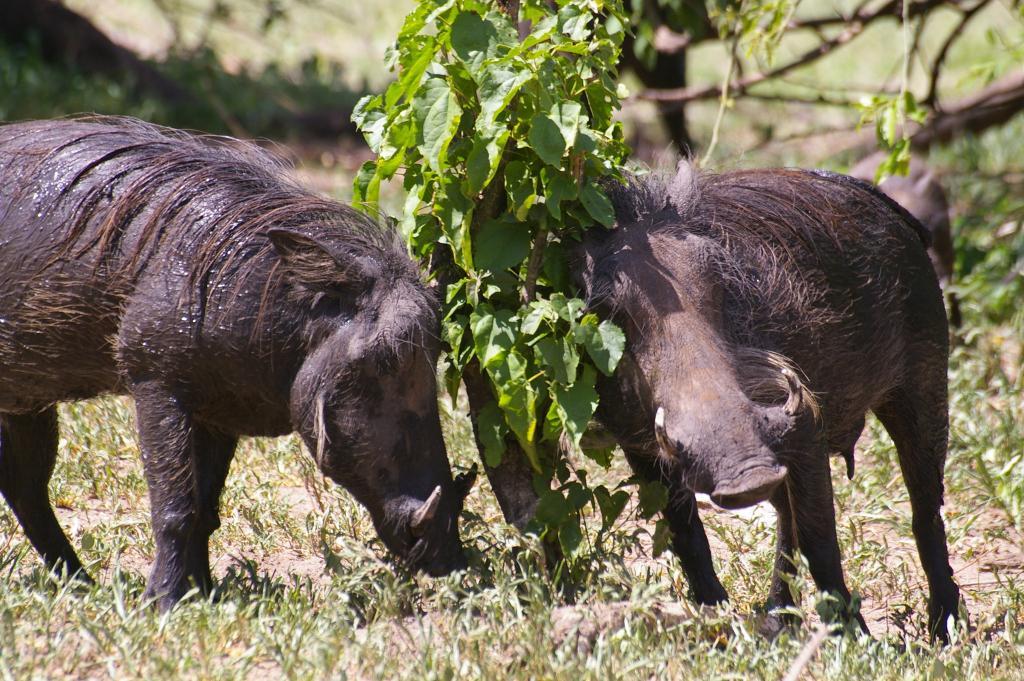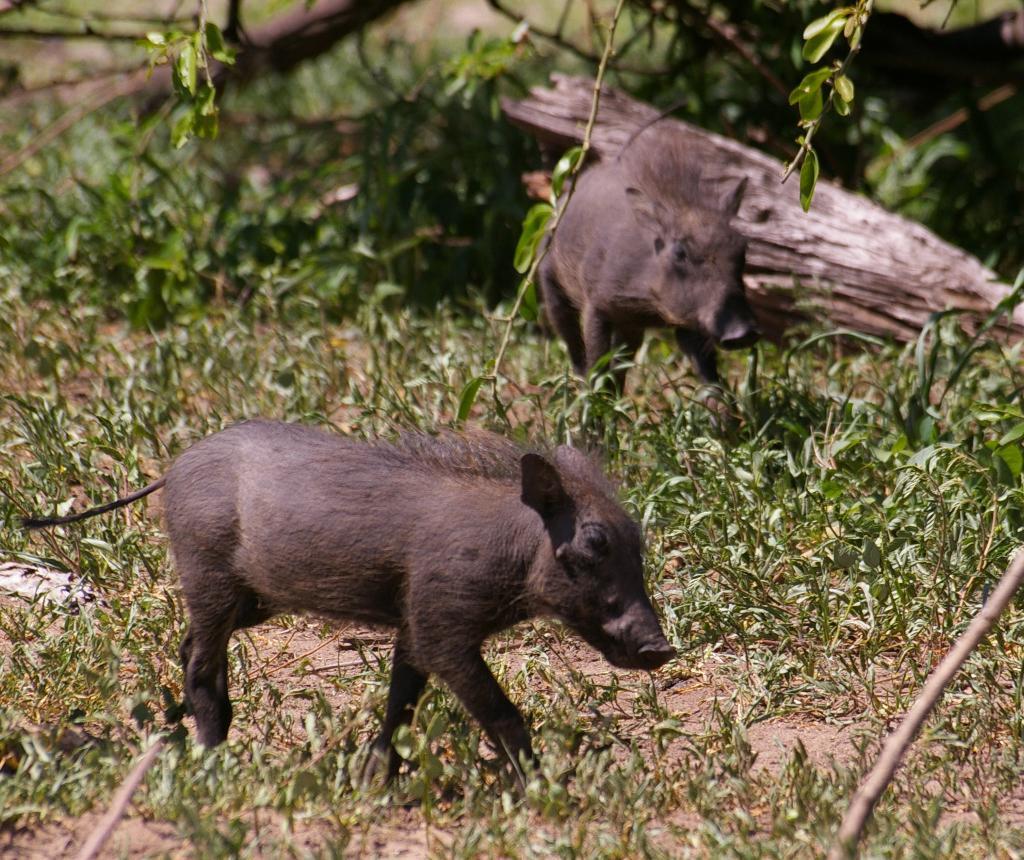The first image is the image on the left, the second image is the image on the right. For the images displayed, is the sentence "In one image, there is at least one animal on top of another one." factually correct? Answer yes or no. No. The first image is the image on the left, the second image is the image on the right. Examine the images to the left and right. Is the description "There are no more than two boars with tusks." accurate? Answer yes or no. Yes. The first image is the image on the left, the second image is the image on the right. Evaluate the accuracy of this statement regarding the images: "Other animals are around the worthog". Is it true? Answer yes or no. No. The first image is the image on the left, the second image is the image on the right. Evaluate the accuracy of this statement regarding the images: "An image includes a warthog that is standing with its front knees on the ground.". Is it true? Answer yes or no. No. 